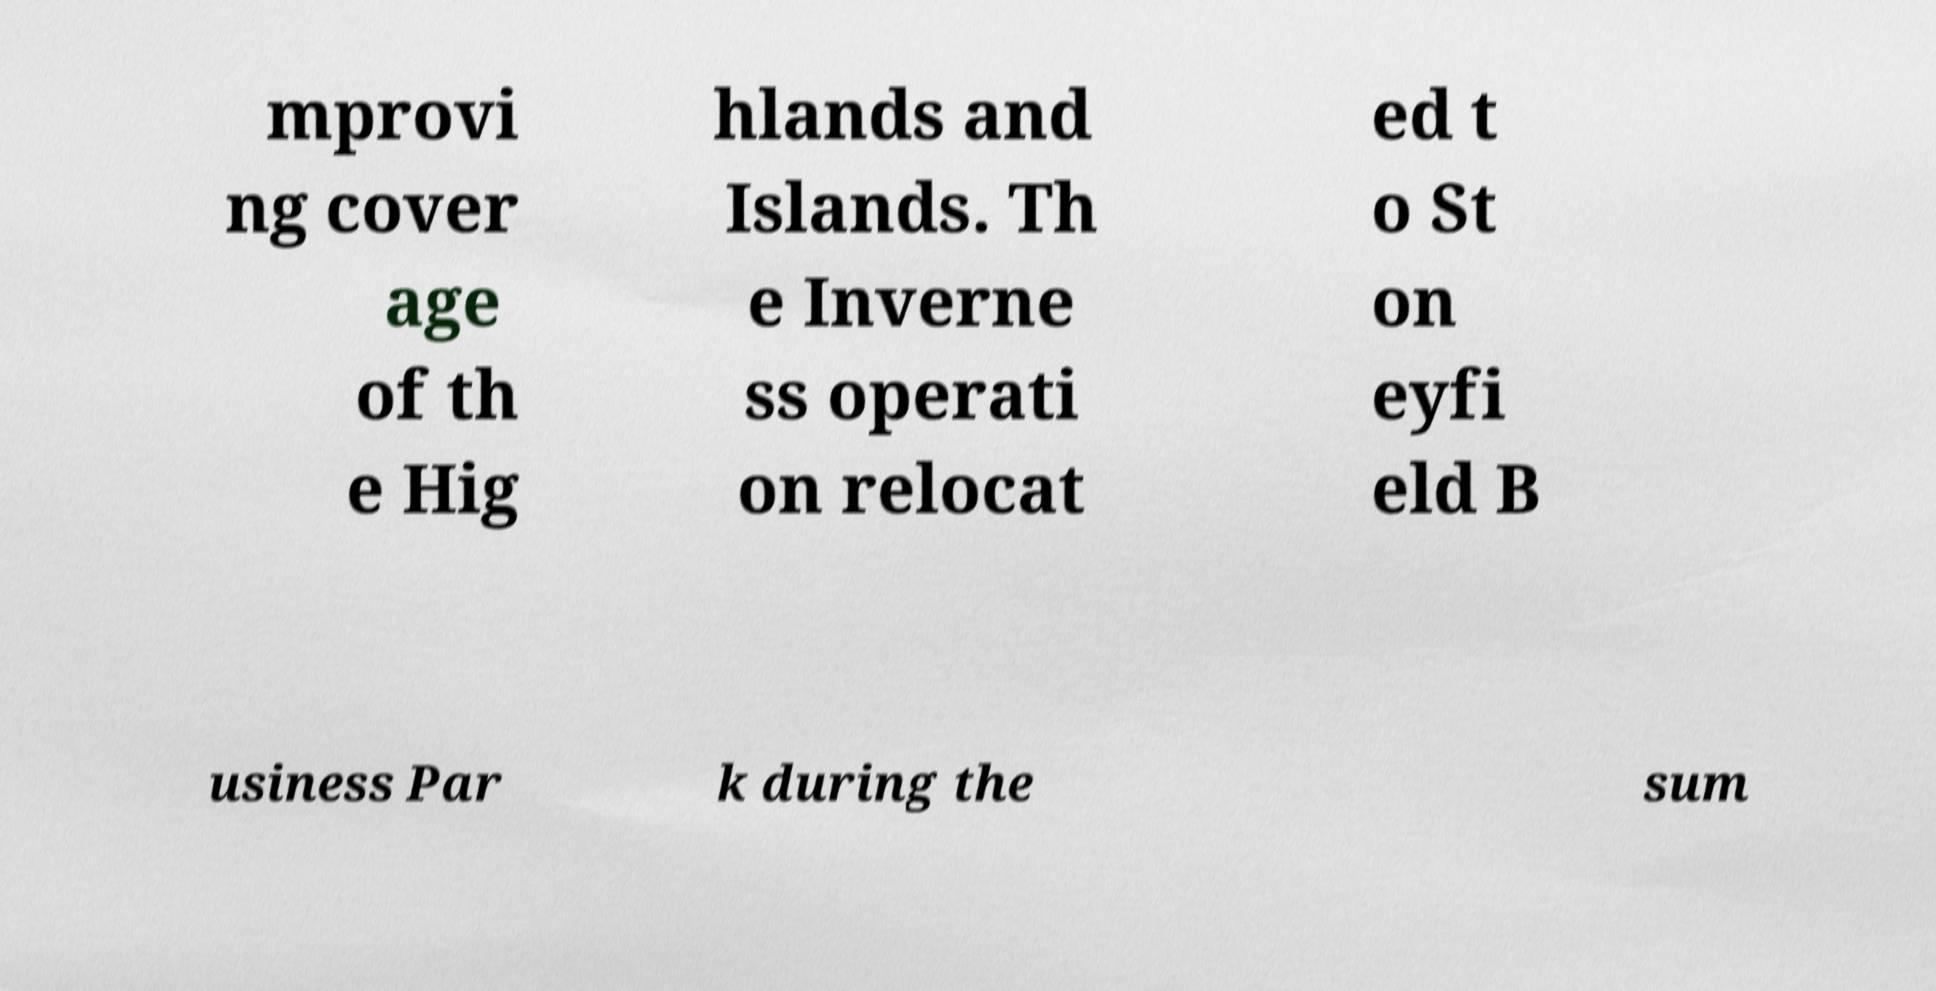There's text embedded in this image that I need extracted. Can you transcribe it verbatim? mprovi ng cover age of th e Hig hlands and Islands. Th e Inverne ss operati on relocat ed t o St on eyfi eld B usiness Par k during the sum 